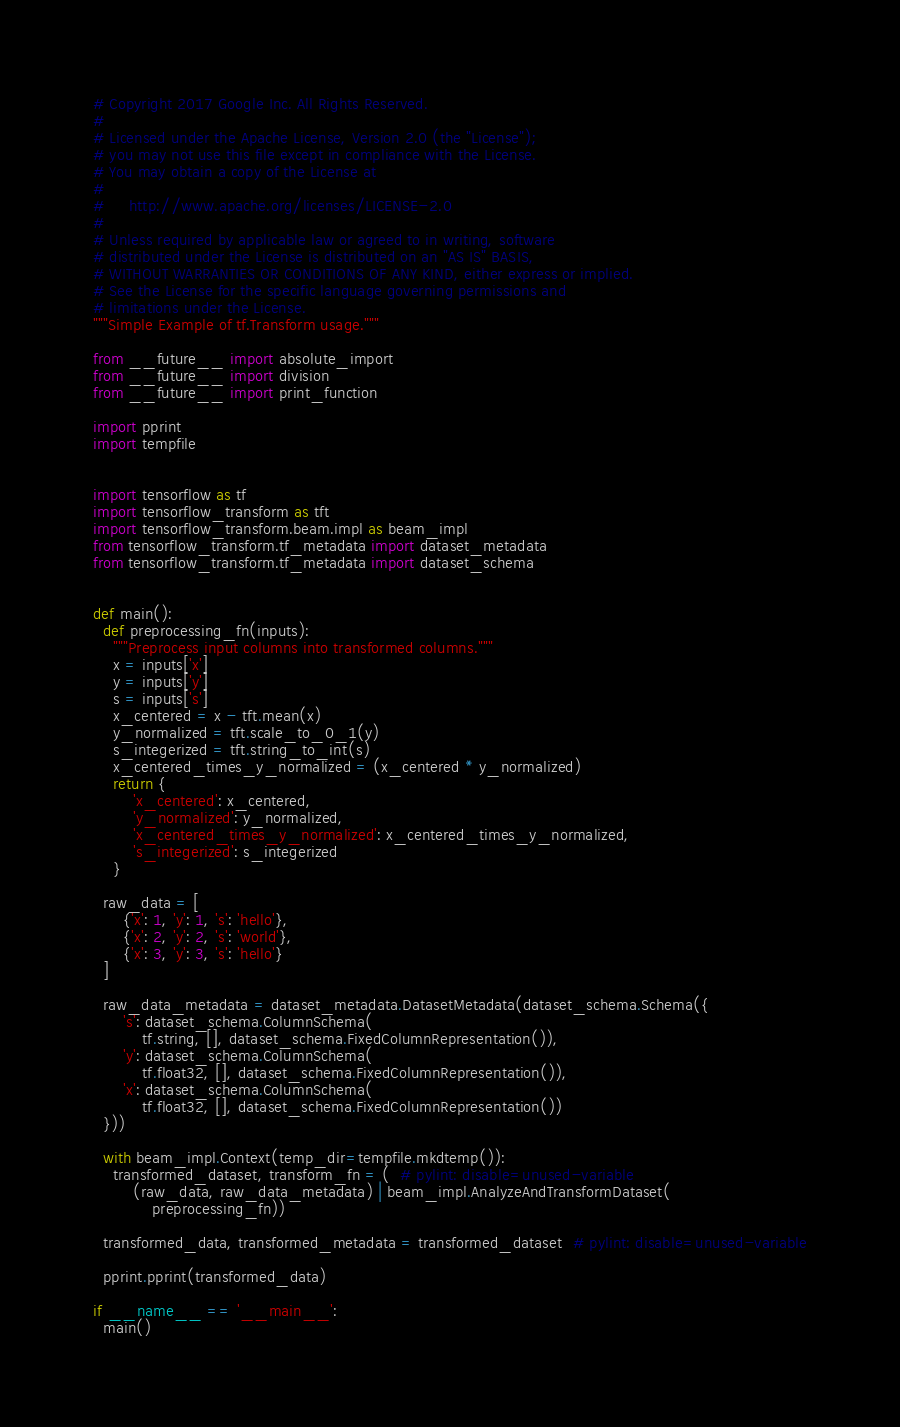Convert code to text. <code><loc_0><loc_0><loc_500><loc_500><_Python_># Copyright 2017 Google Inc. All Rights Reserved.
#
# Licensed under the Apache License, Version 2.0 (the "License");
# you may not use this file except in compliance with the License.
# You may obtain a copy of the License at
#
#     http://www.apache.org/licenses/LICENSE-2.0
#
# Unless required by applicable law or agreed to in writing, software
# distributed under the License is distributed on an "AS IS" BASIS,
# WITHOUT WARRANTIES OR CONDITIONS OF ANY KIND, either express or implied.
# See the License for the specific language governing permissions and
# limitations under the License.
"""Simple Example of tf.Transform usage."""

from __future__ import absolute_import
from __future__ import division
from __future__ import print_function

import pprint
import tempfile


import tensorflow as tf
import tensorflow_transform as tft
import tensorflow_transform.beam.impl as beam_impl
from tensorflow_transform.tf_metadata import dataset_metadata
from tensorflow_transform.tf_metadata import dataset_schema


def main():
  def preprocessing_fn(inputs):
    """Preprocess input columns into transformed columns."""
    x = inputs['x']
    y = inputs['y']
    s = inputs['s']
    x_centered = x - tft.mean(x)
    y_normalized = tft.scale_to_0_1(y)
    s_integerized = tft.string_to_int(s)
    x_centered_times_y_normalized = (x_centered * y_normalized)
    return {
        'x_centered': x_centered,
        'y_normalized': y_normalized,
        'x_centered_times_y_normalized': x_centered_times_y_normalized,
        's_integerized': s_integerized
    }

  raw_data = [
      {'x': 1, 'y': 1, 's': 'hello'},
      {'x': 2, 'y': 2, 's': 'world'},
      {'x': 3, 'y': 3, 's': 'hello'}
  ]

  raw_data_metadata = dataset_metadata.DatasetMetadata(dataset_schema.Schema({
      's': dataset_schema.ColumnSchema(
          tf.string, [], dataset_schema.FixedColumnRepresentation()),
      'y': dataset_schema.ColumnSchema(
          tf.float32, [], dataset_schema.FixedColumnRepresentation()),
      'x': dataset_schema.ColumnSchema(
          tf.float32, [], dataset_schema.FixedColumnRepresentation())
  }))

  with beam_impl.Context(temp_dir=tempfile.mkdtemp()):
    transformed_dataset, transform_fn = (  # pylint: disable=unused-variable
        (raw_data, raw_data_metadata) | beam_impl.AnalyzeAndTransformDataset(
            preprocessing_fn))

  transformed_data, transformed_metadata = transformed_dataset  # pylint: disable=unused-variable

  pprint.pprint(transformed_data)

if __name__ == '__main__':
  main()
</code> 